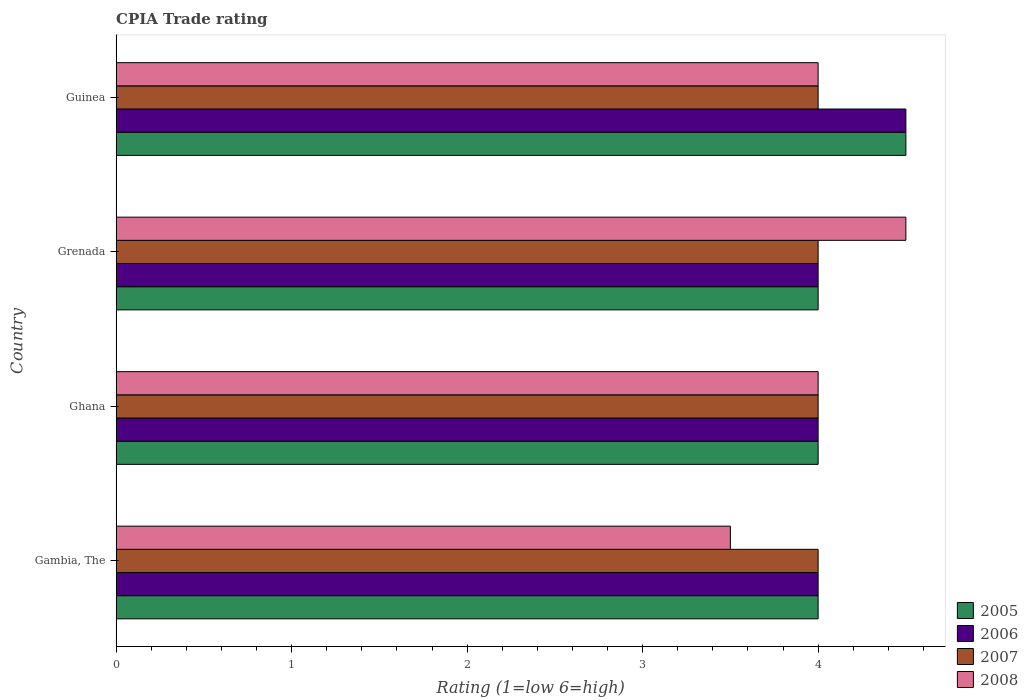How many different coloured bars are there?
Keep it short and to the point. 4. Are the number of bars on each tick of the Y-axis equal?
Ensure brevity in your answer.  Yes. What is the label of the 1st group of bars from the top?
Your answer should be very brief. Guinea. What is the CPIA rating in 2008 in Gambia, The?
Offer a terse response. 3.5. In which country was the CPIA rating in 2006 maximum?
Your response must be concise. Guinea. In which country was the CPIA rating in 2005 minimum?
Offer a terse response. Gambia, The. What is the difference between the CPIA rating in 2005 in Gambia, The and that in Guinea?
Your answer should be compact. -0.5. In how many countries, is the CPIA rating in 2005 greater than 2.8 ?
Provide a short and direct response. 4. Is it the case that in every country, the sum of the CPIA rating in 2006 and CPIA rating in 2008 is greater than the sum of CPIA rating in 2005 and CPIA rating in 2007?
Keep it short and to the point. No. What does the 1st bar from the top in Guinea represents?
Your response must be concise. 2008. Are all the bars in the graph horizontal?
Give a very brief answer. Yes. How many countries are there in the graph?
Make the answer very short. 4. What is the difference between two consecutive major ticks on the X-axis?
Your response must be concise. 1. Are the values on the major ticks of X-axis written in scientific E-notation?
Your response must be concise. No. Does the graph contain grids?
Offer a terse response. No. How many legend labels are there?
Offer a very short reply. 4. What is the title of the graph?
Provide a short and direct response. CPIA Trade rating. What is the Rating (1=low 6=high) of 2005 in Gambia, The?
Offer a terse response. 4. What is the Rating (1=low 6=high) of 2006 in Gambia, The?
Offer a terse response. 4. What is the Rating (1=low 6=high) of 2007 in Ghana?
Provide a short and direct response. 4. What is the Rating (1=low 6=high) in 2008 in Ghana?
Give a very brief answer. 4. What is the Rating (1=low 6=high) in 2007 in Grenada?
Provide a short and direct response. 4. What is the Rating (1=low 6=high) of 2008 in Grenada?
Your response must be concise. 4.5. Across all countries, what is the maximum Rating (1=low 6=high) in 2006?
Offer a very short reply. 4.5. Across all countries, what is the minimum Rating (1=low 6=high) in 2006?
Your response must be concise. 4. Across all countries, what is the minimum Rating (1=low 6=high) of 2008?
Ensure brevity in your answer.  3.5. What is the total Rating (1=low 6=high) of 2005 in the graph?
Provide a succinct answer. 16.5. What is the total Rating (1=low 6=high) of 2008 in the graph?
Give a very brief answer. 16. What is the difference between the Rating (1=low 6=high) of 2005 in Gambia, The and that in Ghana?
Ensure brevity in your answer.  0. What is the difference between the Rating (1=low 6=high) in 2007 in Gambia, The and that in Ghana?
Your answer should be very brief. 0. What is the difference between the Rating (1=low 6=high) of 2006 in Gambia, The and that in Grenada?
Ensure brevity in your answer.  0. What is the difference between the Rating (1=low 6=high) of 2007 in Gambia, The and that in Grenada?
Keep it short and to the point. 0. What is the difference between the Rating (1=low 6=high) of 2005 in Gambia, The and that in Guinea?
Your response must be concise. -0.5. What is the difference between the Rating (1=low 6=high) in 2006 in Gambia, The and that in Guinea?
Ensure brevity in your answer.  -0.5. What is the difference between the Rating (1=low 6=high) in 2005 in Ghana and that in Grenada?
Provide a succinct answer. 0. What is the difference between the Rating (1=low 6=high) of 2006 in Ghana and that in Grenada?
Provide a succinct answer. 0. What is the difference between the Rating (1=low 6=high) of 2007 in Ghana and that in Grenada?
Offer a terse response. 0. What is the difference between the Rating (1=low 6=high) of 2006 in Ghana and that in Guinea?
Your answer should be compact. -0.5. What is the difference between the Rating (1=low 6=high) of 2008 in Ghana and that in Guinea?
Provide a short and direct response. 0. What is the difference between the Rating (1=low 6=high) of 2006 in Grenada and that in Guinea?
Your answer should be very brief. -0.5. What is the difference between the Rating (1=low 6=high) of 2007 in Grenada and that in Guinea?
Keep it short and to the point. 0. What is the difference between the Rating (1=low 6=high) in 2005 in Gambia, The and the Rating (1=low 6=high) in 2006 in Ghana?
Provide a succinct answer. 0. What is the difference between the Rating (1=low 6=high) in 2006 in Gambia, The and the Rating (1=low 6=high) in 2008 in Ghana?
Offer a terse response. 0. What is the difference between the Rating (1=low 6=high) in 2007 in Gambia, The and the Rating (1=low 6=high) in 2008 in Ghana?
Provide a succinct answer. 0. What is the difference between the Rating (1=low 6=high) of 2005 in Gambia, The and the Rating (1=low 6=high) of 2006 in Grenada?
Your answer should be very brief. 0. What is the difference between the Rating (1=low 6=high) of 2005 in Gambia, The and the Rating (1=low 6=high) of 2007 in Grenada?
Ensure brevity in your answer.  0. What is the difference between the Rating (1=low 6=high) of 2005 in Gambia, The and the Rating (1=low 6=high) of 2008 in Grenada?
Make the answer very short. -0.5. What is the difference between the Rating (1=low 6=high) of 2006 in Gambia, The and the Rating (1=low 6=high) of 2007 in Grenada?
Your response must be concise. 0. What is the difference between the Rating (1=low 6=high) of 2007 in Gambia, The and the Rating (1=low 6=high) of 2008 in Grenada?
Ensure brevity in your answer.  -0.5. What is the difference between the Rating (1=low 6=high) of 2006 in Gambia, The and the Rating (1=low 6=high) of 2008 in Guinea?
Keep it short and to the point. 0. What is the difference between the Rating (1=low 6=high) of 2005 in Ghana and the Rating (1=low 6=high) of 2006 in Grenada?
Give a very brief answer. 0. What is the difference between the Rating (1=low 6=high) in 2005 in Ghana and the Rating (1=low 6=high) in 2007 in Grenada?
Your answer should be compact. 0. What is the difference between the Rating (1=low 6=high) in 2005 in Ghana and the Rating (1=low 6=high) in 2008 in Grenada?
Your answer should be very brief. -0.5. What is the difference between the Rating (1=low 6=high) in 2006 in Ghana and the Rating (1=low 6=high) in 2008 in Grenada?
Keep it short and to the point. -0.5. What is the difference between the Rating (1=low 6=high) in 2007 in Ghana and the Rating (1=low 6=high) in 2008 in Grenada?
Offer a very short reply. -0.5. What is the difference between the Rating (1=low 6=high) in 2005 in Ghana and the Rating (1=low 6=high) in 2007 in Guinea?
Keep it short and to the point. 0. What is the difference between the Rating (1=low 6=high) in 2005 in Ghana and the Rating (1=low 6=high) in 2008 in Guinea?
Give a very brief answer. 0. What is the difference between the Rating (1=low 6=high) of 2006 in Ghana and the Rating (1=low 6=high) of 2008 in Guinea?
Offer a terse response. 0. What is the difference between the Rating (1=low 6=high) of 2005 in Grenada and the Rating (1=low 6=high) of 2006 in Guinea?
Give a very brief answer. -0.5. What is the difference between the Rating (1=low 6=high) of 2005 in Grenada and the Rating (1=low 6=high) of 2007 in Guinea?
Ensure brevity in your answer.  0. What is the difference between the Rating (1=low 6=high) of 2005 in Grenada and the Rating (1=low 6=high) of 2008 in Guinea?
Ensure brevity in your answer.  0. What is the difference between the Rating (1=low 6=high) of 2006 in Grenada and the Rating (1=low 6=high) of 2007 in Guinea?
Your answer should be very brief. 0. What is the difference between the Rating (1=low 6=high) of 2006 in Grenada and the Rating (1=low 6=high) of 2008 in Guinea?
Your answer should be very brief. 0. What is the average Rating (1=low 6=high) in 2005 per country?
Provide a short and direct response. 4.12. What is the average Rating (1=low 6=high) in 2006 per country?
Make the answer very short. 4.12. What is the average Rating (1=low 6=high) of 2007 per country?
Your response must be concise. 4. What is the average Rating (1=low 6=high) of 2008 per country?
Make the answer very short. 4. What is the difference between the Rating (1=low 6=high) of 2005 and Rating (1=low 6=high) of 2006 in Gambia, The?
Make the answer very short. 0. What is the difference between the Rating (1=low 6=high) of 2006 and Rating (1=low 6=high) of 2008 in Gambia, The?
Offer a terse response. 0.5. What is the difference between the Rating (1=low 6=high) of 2005 and Rating (1=low 6=high) of 2006 in Ghana?
Ensure brevity in your answer.  0. What is the difference between the Rating (1=low 6=high) of 2006 and Rating (1=low 6=high) of 2007 in Ghana?
Your answer should be very brief. 0. What is the difference between the Rating (1=low 6=high) of 2007 and Rating (1=low 6=high) of 2008 in Ghana?
Your answer should be very brief. 0. What is the difference between the Rating (1=low 6=high) of 2005 and Rating (1=low 6=high) of 2006 in Grenada?
Ensure brevity in your answer.  0. What is the difference between the Rating (1=low 6=high) of 2005 and Rating (1=low 6=high) of 2007 in Grenada?
Make the answer very short. 0. What is the difference between the Rating (1=low 6=high) of 2005 and Rating (1=low 6=high) of 2008 in Grenada?
Your response must be concise. -0.5. What is the difference between the Rating (1=low 6=high) of 2006 and Rating (1=low 6=high) of 2008 in Grenada?
Provide a succinct answer. -0.5. What is the difference between the Rating (1=low 6=high) of 2007 and Rating (1=low 6=high) of 2008 in Grenada?
Make the answer very short. -0.5. What is the difference between the Rating (1=low 6=high) in 2005 and Rating (1=low 6=high) in 2006 in Guinea?
Give a very brief answer. 0. What is the difference between the Rating (1=low 6=high) in 2005 and Rating (1=low 6=high) in 2007 in Guinea?
Keep it short and to the point. 0.5. What is the difference between the Rating (1=low 6=high) of 2006 and Rating (1=low 6=high) of 2007 in Guinea?
Offer a very short reply. 0.5. What is the difference between the Rating (1=low 6=high) of 2006 and Rating (1=low 6=high) of 2008 in Guinea?
Provide a short and direct response. 0.5. What is the ratio of the Rating (1=low 6=high) of 2007 in Gambia, The to that in Ghana?
Give a very brief answer. 1. What is the ratio of the Rating (1=low 6=high) in 2008 in Gambia, The to that in Ghana?
Ensure brevity in your answer.  0.88. What is the ratio of the Rating (1=low 6=high) of 2005 in Gambia, The to that in Grenada?
Keep it short and to the point. 1. What is the ratio of the Rating (1=low 6=high) of 2006 in Gambia, The to that in Grenada?
Provide a succinct answer. 1. What is the ratio of the Rating (1=low 6=high) in 2007 in Gambia, The to that in Grenada?
Make the answer very short. 1. What is the ratio of the Rating (1=low 6=high) of 2006 in Gambia, The to that in Guinea?
Provide a short and direct response. 0.89. What is the ratio of the Rating (1=low 6=high) in 2008 in Gambia, The to that in Guinea?
Offer a very short reply. 0.88. What is the ratio of the Rating (1=low 6=high) of 2006 in Ghana to that in Grenada?
Make the answer very short. 1. What is the ratio of the Rating (1=low 6=high) in 2007 in Ghana to that in Grenada?
Provide a short and direct response. 1. What is the ratio of the Rating (1=low 6=high) of 2008 in Ghana to that in Guinea?
Ensure brevity in your answer.  1. What is the ratio of the Rating (1=low 6=high) in 2008 in Grenada to that in Guinea?
Keep it short and to the point. 1.12. What is the difference between the highest and the second highest Rating (1=low 6=high) of 2005?
Your answer should be compact. 0.5. What is the difference between the highest and the second highest Rating (1=low 6=high) in 2006?
Keep it short and to the point. 0.5. What is the difference between the highest and the second highest Rating (1=low 6=high) of 2008?
Keep it short and to the point. 0.5. What is the difference between the highest and the lowest Rating (1=low 6=high) in 2005?
Ensure brevity in your answer.  0.5. What is the difference between the highest and the lowest Rating (1=low 6=high) in 2006?
Provide a short and direct response. 0.5. 